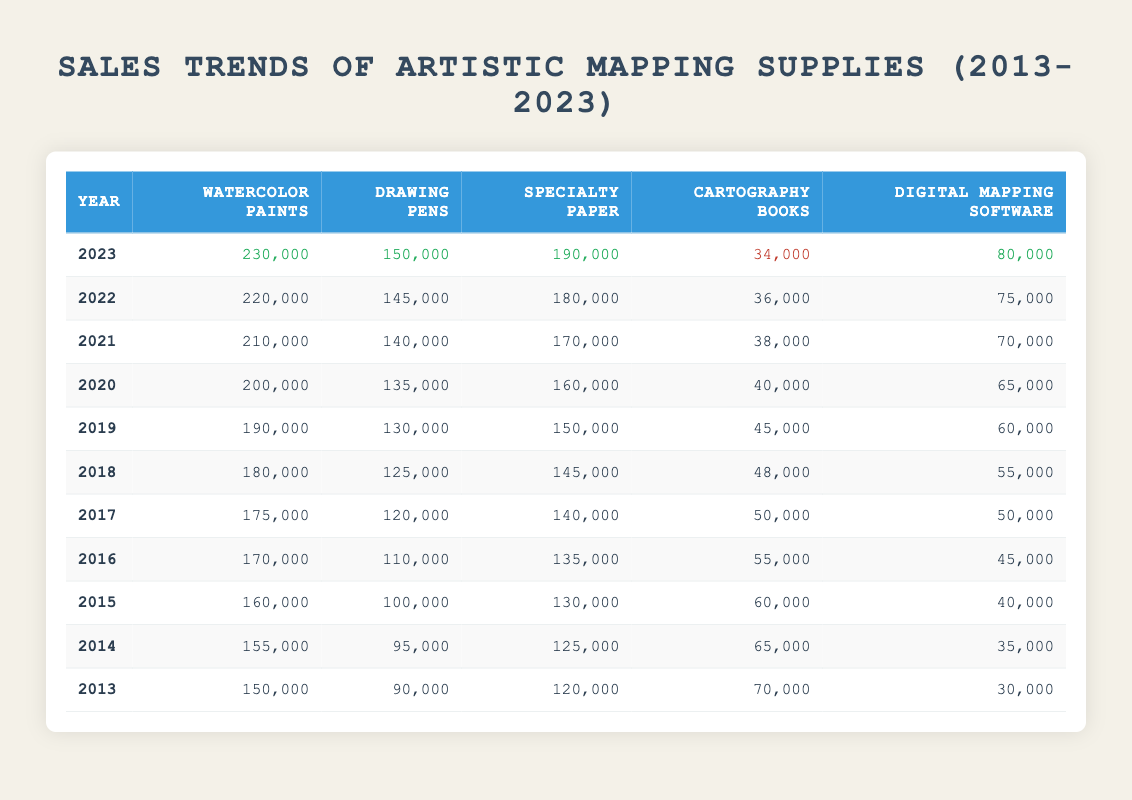What was the sales figure for watercolor paints in 2020? The table shows the sales of watercolor paints for different years. Looking at the row for the year 2020, the sales figure is specified as 200,000.
Answer: 200000 Did the sales of cartography books increase from 2013 to 2023? In 2013, the sales of cartography books were 70,000, and by 2023, they had decreased to 34,000. A decrease indicates that the sales did not increase over this period.
Answer: No What is the average sales figure for drawing pens from 2013 to 2023? The sales figures for drawing pens over the years are: 90,000, 95,000, 100,000, 110,000, 120,000, 125,000, 130,000, 135,000, 140,000, 145,000, and 150,000. Adding these gives a total of 1,325,000 and dividing by 11 years gives an average of approximately 120,455.
Answer: 120455 Which year had the highest sales of specialty paper, and what was the amount? The sales of specialty paper each year are: 120,000 (2013), 125,000 (2014), 130,000 (2015), 135,000 (2016), 140,000 (2017), 145,000 (2018), 150,000 (2019), 160,000 (2020), 170,000 (2021), 180,000 (2022), and 190,000 (2023). The highest figure of 190,000 is found in 2023.
Answer: 2023, 190000 Is it true that digital mapping software sales increased every year? By examining the sales figures for digital mapping software: 30,000 (2013), 35,000 (2014), 40,000 (2015), 45,000 (2016), 50,000 (2017), 55,000 (2018), 60,000 (2019), 65,000 (2020), 70,000 (2021), 75,000 (2022), and 80,000 (2023), we see that there is a consistent increase. Thus, it's true that sales increased each year.
Answer: Yes What was the percentage increase in sales of watercolor paints from 2013 to 2023? The sales of watercolor paints increased from 150,000 in 2013 to 230,000 in 2023. The increase can be calculated as (230,000 - 150,000) / 150,000 * 100, which equals 53.33%. This shows the percentage growth over this period.
Answer: 53.33 In how many of the years did sales of specialty paper exceed 140,000? The sales figures for specialty paper that exceed 140,000 are: 140,000 (2017), 145,000 (2018), 150,000 (2019), 160,000 (2020), 170,000 (2021), 180,000 (2022), and 190,000 (2023). Counting these, there are 7 years where the sales exceeded 140,000.
Answer: 7 Which artistic mapping supply saw the smallest increase in sales between 2013 and 2023? Calculating the increase for each category: Watercolor paints increased by 80,000, drawing pens increased by 60,000, specialty paper increased by 70,000, cartography books decreased by 36,000, and digital mapping software increased by 70,000. The smallest increase is for cartography books, which saw a decrease instead of an increase.
Answer: Cartography books 